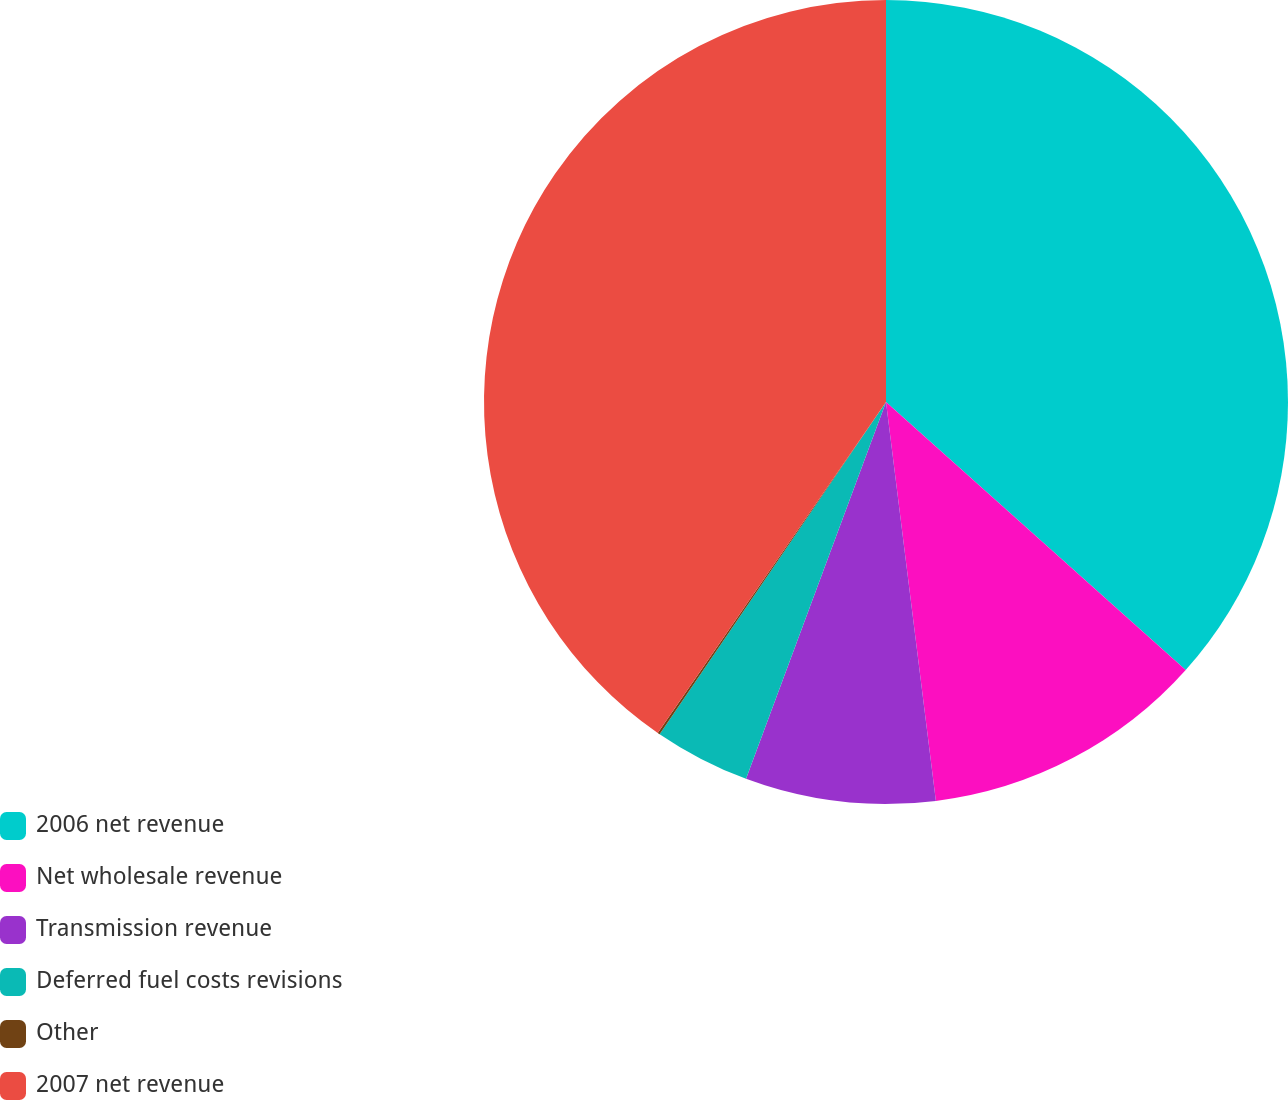Convert chart to OTSL. <chart><loc_0><loc_0><loc_500><loc_500><pie_chart><fcel>2006 net revenue<fcel>Net wholesale revenue<fcel>Transmission revenue<fcel>Deferred fuel costs revisions<fcel>Other<fcel>2007 net revenue<nl><fcel>36.61%<fcel>11.41%<fcel>7.64%<fcel>3.86%<fcel>0.09%<fcel>40.39%<nl></chart> 